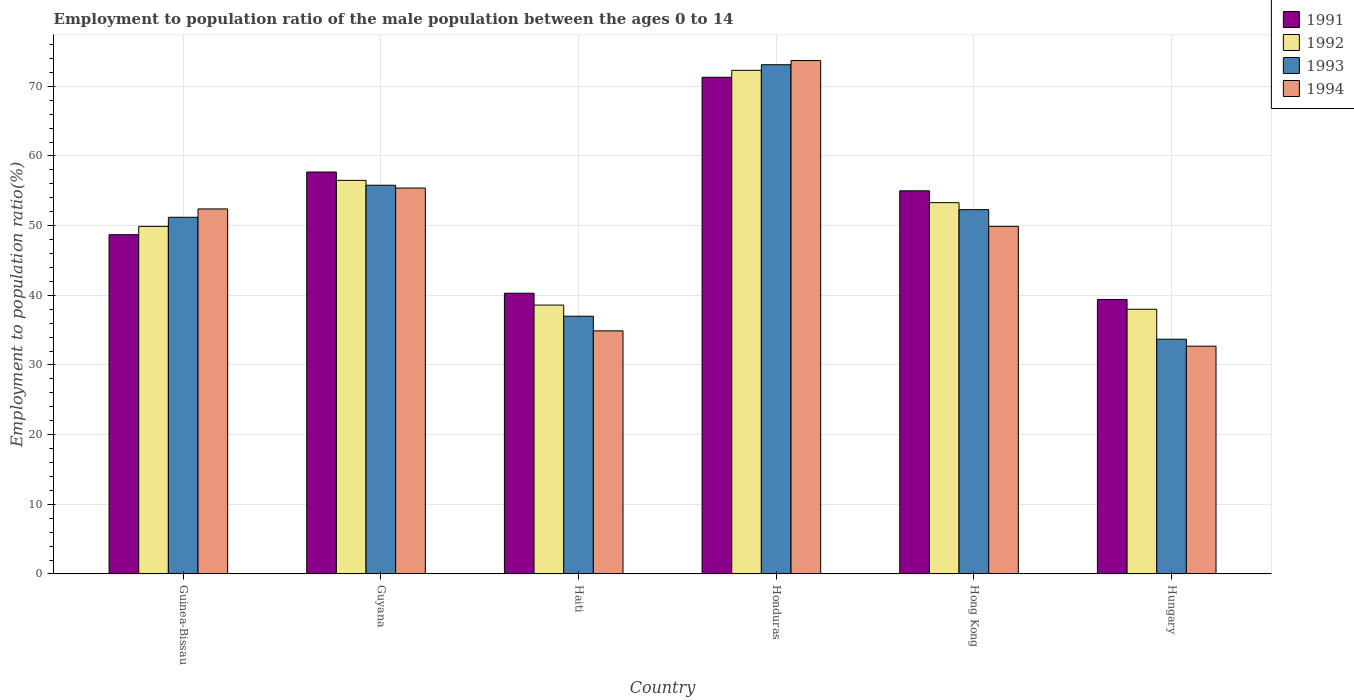How many different coloured bars are there?
Make the answer very short. 4. Are the number of bars per tick equal to the number of legend labels?
Keep it short and to the point. Yes. How many bars are there on the 6th tick from the left?
Provide a short and direct response. 4. How many bars are there on the 6th tick from the right?
Make the answer very short. 4. What is the label of the 5th group of bars from the left?
Make the answer very short. Hong Kong. In how many cases, is the number of bars for a given country not equal to the number of legend labels?
Your answer should be very brief. 0. What is the employment to population ratio in 1994 in Honduras?
Offer a very short reply. 73.7. Across all countries, what is the maximum employment to population ratio in 1992?
Your answer should be compact. 72.3. In which country was the employment to population ratio in 1992 maximum?
Your response must be concise. Honduras. In which country was the employment to population ratio in 1993 minimum?
Give a very brief answer. Hungary. What is the total employment to population ratio in 1991 in the graph?
Your answer should be very brief. 312.4. What is the difference between the employment to population ratio in 1993 in Guinea-Bissau and that in Hong Kong?
Provide a succinct answer. -1.1. What is the difference between the employment to population ratio in 1994 in Guyana and the employment to population ratio in 1993 in Hong Kong?
Your answer should be compact. 3.1. What is the average employment to population ratio in 1991 per country?
Keep it short and to the point. 52.07. In how many countries, is the employment to population ratio in 1994 greater than 52 %?
Offer a terse response. 3. What is the ratio of the employment to population ratio in 1991 in Guinea-Bissau to that in Haiti?
Keep it short and to the point. 1.21. Is the employment to population ratio in 1993 in Guinea-Bissau less than that in Hungary?
Your response must be concise. No. What is the difference between the highest and the second highest employment to population ratio in 1993?
Offer a very short reply. 20.8. What is the difference between the highest and the lowest employment to population ratio in 1994?
Provide a succinct answer. 41. In how many countries, is the employment to population ratio in 1991 greater than the average employment to population ratio in 1991 taken over all countries?
Keep it short and to the point. 3. Is the sum of the employment to population ratio in 1992 in Guinea-Bissau and Guyana greater than the maximum employment to population ratio in 1993 across all countries?
Make the answer very short. Yes. What does the 2nd bar from the left in Haiti represents?
Give a very brief answer. 1992. Is it the case that in every country, the sum of the employment to population ratio in 1993 and employment to population ratio in 1991 is greater than the employment to population ratio in 1994?
Offer a terse response. Yes. Are all the bars in the graph horizontal?
Ensure brevity in your answer.  No. Are the values on the major ticks of Y-axis written in scientific E-notation?
Your answer should be very brief. No. Where does the legend appear in the graph?
Your answer should be compact. Top right. What is the title of the graph?
Offer a very short reply. Employment to population ratio of the male population between the ages 0 to 14. What is the label or title of the X-axis?
Provide a succinct answer. Country. What is the Employment to population ratio(%) in 1991 in Guinea-Bissau?
Ensure brevity in your answer.  48.7. What is the Employment to population ratio(%) of 1992 in Guinea-Bissau?
Your response must be concise. 49.9. What is the Employment to population ratio(%) in 1993 in Guinea-Bissau?
Offer a terse response. 51.2. What is the Employment to population ratio(%) of 1994 in Guinea-Bissau?
Ensure brevity in your answer.  52.4. What is the Employment to population ratio(%) in 1991 in Guyana?
Your response must be concise. 57.7. What is the Employment to population ratio(%) of 1992 in Guyana?
Make the answer very short. 56.5. What is the Employment to population ratio(%) in 1993 in Guyana?
Provide a short and direct response. 55.8. What is the Employment to population ratio(%) in 1994 in Guyana?
Offer a terse response. 55.4. What is the Employment to population ratio(%) of 1991 in Haiti?
Offer a very short reply. 40.3. What is the Employment to population ratio(%) of 1992 in Haiti?
Provide a succinct answer. 38.6. What is the Employment to population ratio(%) in 1994 in Haiti?
Ensure brevity in your answer.  34.9. What is the Employment to population ratio(%) of 1991 in Honduras?
Your answer should be compact. 71.3. What is the Employment to population ratio(%) in 1992 in Honduras?
Provide a succinct answer. 72.3. What is the Employment to population ratio(%) in 1993 in Honduras?
Offer a very short reply. 73.1. What is the Employment to population ratio(%) in 1994 in Honduras?
Offer a terse response. 73.7. What is the Employment to population ratio(%) in 1992 in Hong Kong?
Your response must be concise. 53.3. What is the Employment to population ratio(%) in 1993 in Hong Kong?
Provide a succinct answer. 52.3. What is the Employment to population ratio(%) of 1994 in Hong Kong?
Provide a short and direct response. 49.9. What is the Employment to population ratio(%) of 1991 in Hungary?
Offer a terse response. 39.4. What is the Employment to population ratio(%) in 1992 in Hungary?
Offer a very short reply. 38. What is the Employment to population ratio(%) in 1993 in Hungary?
Your answer should be compact. 33.7. What is the Employment to population ratio(%) of 1994 in Hungary?
Your response must be concise. 32.7. Across all countries, what is the maximum Employment to population ratio(%) of 1991?
Give a very brief answer. 71.3. Across all countries, what is the maximum Employment to population ratio(%) in 1992?
Make the answer very short. 72.3. Across all countries, what is the maximum Employment to population ratio(%) in 1993?
Ensure brevity in your answer.  73.1. Across all countries, what is the maximum Employment to population ratio(%) of 1994?
Provide a succinct answer. 73.7. Across all countries, what is the minimum Employment to population ratio(%) in 1991?
Offer a terse response. 39.4. Across all countries, what is the minimum Employment to population ratio(%) of 1992?
Make the answer very short. 38. Across all countries, what is the minimum Employment to population ratio(%) in 1993?
Keep it short and to the point. 33.7. Across all countries, what is the minimum Employment to population ratio(%) of 1994?
Offer a very short reply. 32.7. What is the total Employment to population ratio(%) of 1991 in the graph?
Keep it short and to the point. 312.4. What is the total Employment to population ratio(%) of 1992 in the graph?
Your answer should be very brief. 308.6. What is the total Employment to population ratio(%) of 1993 in the graph?
Your answer should be compact. 303.1. What is the total Employment to population ratio(%) of 1994 in the graph?
Provide a succinct answer. 299. What is the difference between the Employment to population ratio(%) in 1991 in Guinea-Bissau and that in Guyana?
Your response must be concise. -9. What is the difference between the Employment to population ratio(%) of 1992 in Guinea-Bissau and that in Guyana?
Ensure brevity in your answer.  -6.6. What is the difference between the Employment to population ratio(%) in 1993 in Guinea-Bissau and that in Guyana?
Keep it short and to the point. -4.6. What is the difference between the Employment to population ratio(%) in 1991 in Guinea-Bissau and that in Haiti?
Your answer should be very brief. 8.4. What is the difference between the Employment to population ratio(%) in 1992 in Guinea-Bissau and that in Haiti?
Make the answer very short. 11.3. What is the difference between the Employment to population ratio(%) of 1993 in Guinea-Bissau and that in Haiti?
Your response must be concise. 14.2. What is the difference between the Employment to population ratio(%) of 1991 in Guinea-Bissau and that in Honduras?
Keep it short and to the point. -22.6. What is the difference between the Employment to population ratio(%) in 1992 in Guinea-Bissau and that in Honduras?
Provide a succinct answer. -22.4. What is the difference between the Employment to population ratio(%) of 1993 in Guinea-Bissau and that in Honduras?
Your answer should be compact. -21.9. What is the difference between the Employment to population ratio(%) in 1994 in Guinea-Bissau and that in Honduras?
Your response must be concise. -21.3. What is the difference between the Employment to population ratio(%) of 1991 in Guinea-Bissau and that in Hong Kong?
Provide a succinct answer. -6.3. What is the difference between the Employment to population ratio(%) in 1992 in Guinea-Bissau and that in Hong Kong?
Provide a succinct answer. -3.4. What is the difference between the Employment to population ratio(%) of 1993 in Guinea-Bissau and that in Hong Kong?
Keep it short and to the point. -1.1. What is the difference between the Employment to population ratio(%) of 1994 in Guinea-Bissau and that in Hong Kong?
Give a very brief answer. 2.5. What is the difference between the Employment to population ratio(%) of 1992 in Guyana and that in Haiti?
Give a very brief answer. 17.9. What is the difference between the Employment to population ratio(%) of 1993 in Guyana and that in Haiti?
Provide a short and direct response. 18.8. What is the difference between the Employment to population ratio(%) of 1991 in Guyana and that in Honduras?
Provide a short and direct response. -13.6. What is the difference between the Employment to population ratio(%) of 1992 in Guyana and that in Honduras?
Provide a short and direct response. -15.8. What is the difference between the Employment to population ratio(%) of 1993 in Guyana and that in Honduras?
Make the answer very short. -17.3. What is the difference between the Employment to population ratio(%) of 1994 in Guyana and that in Honduras?
Give a very brief answer. -18.3. What is the difference between the Employment to population ratio(%) of 1991 in Guyana and that in Hong Kong?
Provide a short and direct response. 2.7. What is the difference between the Employment to population ratio(%) of 1991 in Guyana and that in Hungary?
Give a very brief answer. 18.3. What is the difference between the Employment to population ratio(%) of 1993 in Guyana and that in Hungary?
Your response must be concise. 22.1. What is the difference between the Employment to population ratio(%) of 1994 in Guyana and that in Hungary?
Your answer should be compact. 22.7. What is the difference between the Employment to population ratio(%) of 1991 in Haiti and that in Honduras?
Your answer should be very brief. -31. What is the difference between the Employment to population ratio(%) of 1992 in Haiti and that in Honduras?
Your response must be concise. -33.7. What is the difference between the Employment to population ratio(%) in 1993 in Haiti and that in Honduras?
Offer a very short reply. -36.1. What is the difference between the Employment to population ratio(%) of 1994 in Haiti and that in Honduras?
Make the answer very short. -38.8. What is the difference between the Employment to population ratio(%) of 1991 in Haiti and that in Hong Kong?
Keep it short and to the point. -14.7. What is the difference between the Employment to population ratio(%) in 1992 in Haiti and that in Hong Kong?
Give a very brief answer. -14.7. What is the difference between the Employment to population ratio(%) of 1993 in Haiti and that in Hong Kong?
Your answer should be very brief. -15.3. What is the difference between the Employment to population ratio(%) of 1994 in Haiti and that in Hungary?
Offer a very short reply. 2.2. What is the difference between the Employment to population ratio(%) of 1991 in Honduras and that in Hong Kong?
Make the answer very short. 16.3. What is the difference between the Employment to population ratio(%) in 1992 in Honduras and that in Hong Kong?
Your answer should be compact. 19. What is the difference between the Employment to population ratio(%) of 1993 in Honduras and that in Hong Kong?
Offer a very short reply. 20.8. What is the difference between the Employment to population ratio(%) in 1994 in Honduras and that in Hong Kong?
Your response must be concise. 23.8. What is the difference between the Employment to population ratio(%) in 1991 in Honduras and that in Hungary?
Provide a succinct answer. 31.9. What is the difference between the Employment to population ratio(%) of 1992 in Honduras and that in Hungary?
Provide a short and direct response. 34.3. What is the difference between the Employment to population ratio(%) in 1993 in Honduras and that in Hungary?
Make the answer very short. 39.4. What is the difference between the Employment to population ratio(%) in 1993 in Hong Kong and that in Hungary?
Provide a succinct answer. 18.6. What is the difference between the Employment to population ratio(%) in 1994 in Hong Kong and that in Hungary?
Offer a very short reply. 17.2. What is the difference between the Employment to population ratio(%) in 1991 in Guinea-Bissau and the Employment to population ratio(%) in 1992 in Guyana?
Provide a short and direct response. -7.8. What is the difference between the Employment to population ratio(%) in 1991 in Guinea-Bissau and the Employment to population ratio(%) in 1993 in Guyana?
Your answer should be compact. -7.1. What is the difference between the Employment to population ratio(%) in 1993 in Guinea-Bissau and the Employment to population ratio(%) in 1994 in Guyana?
Make the answer very short. -4.2. What is the difference between the Employment to population ratio(%) of 1991 in Guinea-Bissau and the Employment to population ratio(%) of 1993 in Haiti?
Your answer should be very brief. 11.7. What is the difference between the Employment to population ratio(%) of 1991 in Guinea-Bissau and the Employment to population ratio(%) of 1994 in Haiti?
Ensure brevity in your answer.  13.8. What is the difference between the Employment to population ratio(%) in 1992 in Guinea-Bissau and the Employment to population ratio(%) in 1993 in Haiti?
Make the answer very short. 12.9. What is the difference between the Employment to population ratio(%) in 1992 in Guinea-Bissau and the Employment to population ratio(%) in 1994 in Haiti?
Offer a terse response. 15. What is the difference between the Employment to population ratio(%) of 1991 in Guinea-Bissau and the Employment to population ratio(%) of 1992 in Honduras?
Make the answer very short. -23.6. What is the difference between the Employment to population ratio(%) of 1991 in Guinea-Bissau and the Employment to population ratio(%) of 1993 in Honduras?
Offer a very short reply. -24.4. What is the difference between the Employment to population ratio(%) of 1991 in Guinea-Bissau and the Employment to population ratio(%) of 1994 in Honduras?
Provide a succinct answer. -25. What is the difference between the Employment to population ratio(%) in 1992 in Guinea-Bissau and the Employment to population ratio(%) in 1993 in Honduras?
Keep it short and to the point. -23.2. What is the difference between the Employment to population ratio(%) in 1992 in Guinea-Bissau and the Employment to population ratio(%) in 1994 in Honduras?
Provide a short and direct response. -23.8. What is the difference between the Employment to population ratio(%) of 1993 in Guinea-Bissau and the Employment to population ratio(%) of 1994 in Honduras?
Your answer should be compact. -22.5. What is the difference between the Employment to population ratio(%) of 1991 in Guinea-Bissau and the Employment to population ratio(%) of 1993 in Hong Kong?
Offer a very short reply. -3.6. What is the difference between the Employment to population ratio(%) of 1991 in Guinea-Bissau and the Employment to population ratio(%) of 1994 in Hong Kong?
Provide a succinct answer. -1.2. What is the difference between the Employment to population ratio(%) in 1992 in Guinea-Bissau and the Employment to population ratio(%) in 1994 in Hong Kong?
Make the answer very short. 0. What is the difference between the Employment to population ratio(%) of 1991 in Guinea-Bissau and the Employment to population ratio(%) of 1992 in Hungary?
Provide a short and direct response. 10.7. What is the difference between the Employment to population ratio(%) in 1991 in Guinea-Bissau and the Employment to population ratio(%) in 1993 in Hungary?
Make the answer very short. 15. What is the difference between the Employment to population ratio(%) in 1992 in Guinea-Bissau and the Employment to population ratio(%) in 1993 in Hungary?
Your response must be concise. 16.2. What is the difference between the Employment to population ratio(%) in 1991 in Guyana and the Employment to population ratio(%) in 1993 in Haiti?
Your response must be concise. 20.7. What is the difference between the Employment to population ratio(%) in 1991 in Guyana and the Employment to population ratio(%) in 1994 in Haiti?
Keep it short and to the point. 22.8. What is the difference between the Employment to population ratio(%) in 1992 in Guyana and the Employment to population ratio(%) in 1994 in Haiti?
Keep it short and to the point. 21.6. What is the difference between the Employment to population ratio(%) in 1993 in Guyana and the Employment to population ratio(%) in 1994 in Haiti?
Offer a very short reply. 20.9. What is the difference between the Employment to population ratio(%) in 1991 in Guyana and the Employment to population ratio(%) in 1992 in Honduras?
Provide a succinct answer. -14.6. What is the difference between the Employment to population ratio(%) in 1991 in Guyana and the Employment to population ratio(%) in 1993 in Honduras?
Provide a succinct answer. -15.4. What is the difference between the Employment to population ratio(%) of 1991 in Guyana and the Employment to population ratio(%) of 1994 in Honduras?
Offer a terse response. -16. What is the difference between the Employment to population ratio(%) in 1992 in Guyana and the Employment to population ratio(%) in 1993 in Honduras?
Ensure brevity in your answer.  -16.6. What is the difference between the Employment to population ratio(%) of 1992 in Guyana and the Employment to population ratio(%) of 1994 in Honduras?
Make the answer very short. -17.2. What is the difference between the Employment to population ratio(%) of 1993 in Guyana and the Employment to population ratio(%) of 1994 in Honduras?
Offer a very short reply. -17.9. What is the difference between the Employment to population ratio(%) in 1991 in Guyana and the Employment to population ratio(%) in 1993 in Hong Kong?
Give a very brief answer. 5.4. What is the difference between the Employment to population ratio(%) of 1991 in Guyana and the Employment to population ratio(%) of 1994 in Hong Kong?
Give a very brief answer. 7.8. What is the difference between the Employment to population ratio(%) in 1992 in Guyana and the Employment to population ratio(%) in 1994 in Hong Kong?
Give a very brief answer. 6.6. What is the difference between the Employment to population ratio(%) in 1993 in Guyana and the Employment to population ratio(%) in 1994 in Hong Kong?
Make the answer very short. 5.9. What is the difference between the Employment to population ratio(%) in 1991 in Guyana and the Employment to population ratio(%) in 1993 in Hungary?
Keep it short and to the point. 24. What is the difference between the Employment to population ratio(%) of 1991 in Guyana and the Employment to population ratio(%) of 1994 in Hungary?
Your answer should be very brief. 25. What is the difference between the Employment to population ratio(%) of 1992 in Guyana and the Employment to population ratio(%) of 1993 in Hungary?
Give a very brief answer. 22.8. What is the difference between the Employment to population ratio(%) of 1992 in Guyana and the Employment to population ratio(%) of 1994 in Hungary?
Provide a short and direct response. 23.8. What is the difference between the Employment to population ratio(%) of 1993 in Guyana and the Employment to population ratio(%) of 1994 in Hungary?
Make the answer very short. 23.1. What is the difference between the Employment to population ratio(%) of 1991 in Haiti and the Employment to population ratio(%) of 1992 in Honduras?
Provide a succinct answer. -32. What is the difference between the Employment to population ratio(%) in 1991 in Haiti and the Employment to population ratio(%) in 1993 in Honduras?
Ensure brevity in your answer.  -32.8. What is the difference between the Employment to population ratio(%) of 1991 in Haiti and the Employment to population ratio(%) of 1994 in Honduras?
Provide a succinct answer. -33.4. What is the difference between the Employment to population ratio(%) of 1992 in Haiti and the Employment to population ratio(%) of 1993 in Honduras?
Ensure brevity in your answer.  -34.5. What is the difference between the Employment to population ratio(%) in 1992 in Haiti and the Employment to population ratio(%) in 1994 in Honduras?
Make the answer very short. -35.1. What is the difference between the Employment to population ratio(%) in 1993 in Haiti and the Employment to population ratio(%) in 1994 in Honduras?
Keep it short and to the point. -36.7. What is the difference between the Employment to population ratio(%) in 1991 in Haiti and the Employment to population ratio(%) in 1992 in Hong Kong?
Ensure brevity in your answer.  -13. What is the difference between the Employment to population ratio(%) of 1992 in Haiti and the Employment to population ratio(%) of 1993 in Hong Kong?
Your answer should be compact. -13.7. What is the difference between the Employment to population ratio(%) of 1992 in Haiti and the Employment to population ratio(%) of 1994 in Hong Kong?
Keep it short and to the point. -11.3. What is the difference between the Employment to population ratio(%) in 1993 in Haiti and the Employment to population ratio(%) in 1994 in Hong Kong?
Your answer should be very brief. -12.9. What is the difference between the Employment to population ratio(%) in 1991 in Haiti and the Employment to population ratio(%) in 1992 in Hungary?
Ensure brevity in your answer.  2.3. What is the difference between the Employment to population ratio(%) in 1991 in Haiti and the Employment to population ratio(%) in 1994 in Hungary?
Make the answer very short. 7.6. What is the difference between the Employment to population ratio(%) in 1992 in Haiti and the Employment to population ratio(%) in 1994 in Hungary?
Ensure brevity in your answer.  5.9. What is the difference between the Employment to population ratio(%) in 1991 in Honduras and the Employment to population ratio(%) in 1994 in Hong Kong?
Your answer should be very brief. 21.4. What is the difference between the Employment to population ratio(%) in 1992 in Honduras and the Employment to population ratio(%) in 1994 in Hong Kong?
Give a very brief answer. 22.4. What is the difference between the Employment to population ratio(%) of 1993 in Honduras and the Employment to population ratio(%) of 1994 in Hong Kong?
Ensure brevity in your answer.  23.2. What is the difference between the Employment to population ratio(%) of 1991 in Honduras and the Employment to population ratio(%) of 1992 in Hungary?
Give a very brief answer. 33.3. What is the difference between the Employment to population ratio(%) in 1991 in Honduras and the Employment to population ratio(%) in 1993 in Hungary?
Your answer should be very brief. 37.6. What is the difference between the Employment to population ratio(%) in 1991 in Honduras and the Employment to population ratio(%) in 1994 in Hungary?
Your answer should be compact. 38.6. What is the difference between the Employment to population ratio(%) in 1992 in Honduras and the Employment to population ratio(%) in 1993 in Hungary?
Your response must be concise. 38.6. What is the difference between the Employment to population ratio(%) of 1992 in Honduras and the Employment to population ratio(%) of 1994 in Hungary?
Your answer should be compact. 39.6. What is the difference between the Employment to population ratio(%) of 1993 in Honduras and the Employment to population ratio(%) of 1994 in Hungary?
Offer a terse response. 40.4. What is the difference between the Employment to population ratio(%) in 1991 in Hong Kong and the Employment to population ratio(%) in 1992 in Hungary?
Your response must be concise. 17. What is the difference between the Employment to population ratio(%) of 1991 in Hong Kong and the Employment to population ratio(%) of 1993 in Hungary?
Your response must be concise. 21.3. What is the difference between the Employment to population ratio(%) of 1991 in Hong Kong and the Employment to population ratio(%) of 1994 in Hungary?
Provide a succinct answer. 22.3. What is the difference between the Employment to population ratio(%) of 1992 in Hong Kong and the Employment to population ratio(%) of 1993 in Hungary?
Make the answer very short. 19.6. What is the difference between the Employment to population ratio(%) of 1992 in Hong Kong and the Employment to population ratio(%) of 1994 in Hungary?
Provide a succinct answer. 20.6. What is the difference between the Employment to population ratio(%) in 1993 in Hong Kong and the Employment to population ratio(%) in 1994 in Hungary?
Offer a very short reply. 19.6. What is the average Employment to population ratio(%) in 1991 per country?
Your answer should be compact. 52.07. What is the average Employment to population ratio(%) of 1992 per country?
Provide a succinct answer. 51.43. What is the average Employment to population ratio(%) of 1993 per country?
Provide a short and direct response. 50.52. What is the average Employment to population ratio(%) of 1994 per country?
Offer a terse response. 49.83. What is the difference between the Employment to population ratio(%) in 1991 and Employment to population ratio(%) in 1994 in Guinea-Bissau?
Ensure brevity in your answer.  -3.7. What is the difference between the Employment to population ratio(%) in 1993 and Employment to population ratio(%) in 1994 in Guinea-Bissau?
Your response must be concise. -1.2. What is the difference between the Employment to population ratio(%) of 1991 and Employment to population ratio(%) of 1992 in Guyana?
Your answer should be compact. 1.2. What is the difference between the Employment to population ratio(%) of 1993 and Employment to population ratio(%) of 1994 in Guyana?
Your answer should be very brief. 0.4. What is the difference between the Employment to population ratio(%) of 1992 and Employment to population ratio(%) of 1993 in Honduras?
Provide a short and direct response. -0.8. What is the difference between the Employment to population ratio(%) of 1992 and Employment to population ratio(%) of 1994 in Honduras?
Keep it short and to the point. -1.4. What is the difference between the Employment to population ratio(%) of 1991 and Employment to population ratio(%) of 1993 in Hong Kong?
Offer a terse response. 2.7. What is the difference between the Employment to population ratio(%) in 1991 and Employment to population ratio(%) in 1994 in Hong Kong?
Your response must be concise. 5.1. What is the difference between the Employment to population ratio(%) of 1991 and Employment to population ratio(%) of 1992 in Hungary?
Your answer should be very brief. 1.4. What is the difference between the Employment to population ratio(%) of 1993 and Employment to population ratio(%) of 1994 in Hungary?
Ensure brevity in your answer.  1. What is the ratio of the Employment to population ratio(%) in 1991 in Guinea-Bissau to that in Guyana?
Your answer should be compact. 0.84. What is the ratio of the Employment to population ratio(%) in 1992 in Guinea-Bissau to that in Guyana?
Keep it short and to the point. 0.88. What is the ratio of the Employment to population ratio(%) of 1993 in Guinea-Bissau to that in Guyana?
Offer a terse response. 0.92. What is the ratio of the Employment to population ratio(%) of 1994 in Guinea-Bissau to that in Guyana?
Make the answer very short. 0.95. What is the ratio of the Employment to population ratio(%) in 1991 in Guinea-Bissau to that in Haiti?
Provide a short and direct response. 1.21. What is the ratio of the Employment to population ratio(%) in 1992 in Guinea-Bissau to that in Haiti?
Make the answer very short. 1.29. What is the ratio of the Employment to population ratio(%) of 1993 in Guinea-Bissau to that in Haiti?
Ensure brevity in your answer.  1.38. What is the ratio of the Employment to population ratio(%) in 1994 in Guinea-Bissau to that in Haiti?
Offer a terse response. 1.5. What is the ratio of the Employment to population ratio(%) in 1991 in Guinea-Bissau to that in Honduras?
Your response must be concise. 0.68. What is the ratio of the Employment to population ratio(%) of 1992 in Guinea-Bissau to that in Honduras?
Your answer should be very brief. 0.69. What is the ratio of the Employment to population ratio(%) in 1993 in Guinea-Bissau to that in Honduras?
Ensure brevity in your answer.  0.7. What is the ratio of the Employment to population ratio(%) in 1994 in Guinea-Bissau to that in Honduras?
Ensure brevity in your answer.  0.71. What is the ratio of the Employment to population ratio(%) of 1991 in Guinea-Bissau to that in Hong Kong?
Offer a very short reply. 0.89. What is the ratio of the Employment to population ratio(%) in 1992 in Guinea-Bissau to that in Hong Kong?
Your answer should be very brief. 0.94. What is the ratio of the Employment to population ratio(%) of 1993 in Guinea-Bissau to that in Hong Kong?
Provide a succinct answer. 0.98. What is the ratio of the Employment to population ratio(%) in 1994 in Guinea-Bissau to that in Hong Kong?
Offer a very short reply. 1.05. What is the ratio of the Employment to population ratio(%) in 1991 in Guinea-Bissau to that in Hungary?
Your answer should be very brief. 1.24. What is the ratio of the Employment to population ratio(%) of 1992 in Guinea-Bissau to that in Hungary?
Ensure brevity in your answer.  1.31. What is the ratio of the Employment to population ratio(%) in 1993 in Guinea-Bissau to that in Hungary?
Give a very brief answer. 1.52. What is the ratio of the Employment to population ratio(%) of 1994 in Guinea-Bissau to that in Hungary?
Offer a terse response. 1.6. What is the ratio of the Employment to population ratio(%) of 1991 in Guyana to that in Haiti?
Your answer should be compact. 1.43. What is the ratio of the Employment to population ratio(%) in 1992 in Guyana to that in Haiti?
Provide a short and direct response. 1.46. What is the ratio of the Employment to population ratio(%) in 1993 in Guyana to that in Haiti?
Keep it short and to the point. 1.51. What is the ratio of the Employment to population ratio(%) in 1994 in Guyana to that in Haiti?
Offer a very short reply. 1.59. What is the ratio of the Employment to population ratio(%) of 1991 in Guyana to that in Honduras?
Provide a short and direct response. 0.81. What is the ratio of the Employment to population ratio(%) in 1992 in Guyana to that in Honduras?
Provide a succinct answer. 0.78. What is the ratio of the Employment to population ratio(%) of 1993 in Guyana to that in Honduras?
Offer a terse response. 0.76. What is the ratio of the Employment to population ratio(%) in 1994 in Guyana to that in Honduras?
Provide a succinct answer. 0.75. What is the ratio of the Employment to population ratio(%) in 1991 in Guyana to that in Hong Kong?
Ensure brevity in your answer.  1.05. What is the ratio of the Employment to population ratio(%) of 1992 in Guyana to that in Hong Kong?
Give a very brief answer. 1.06. What is the ratio of the Employment to population ratio(%) of 1993 in Guyana to that in Hong Kong?
Your response must be concise. 1.07. What is the ratio of the Employment to population ratio(%) in 1994 in Guyana to that in Hong Kong?
Keep it short and to the point. 1.11. What is the ratio of the Employment to population ratio(%) of 1991 in Guyana to that in Hungary?
Make the answer very short. 1.46. What is the ratio of the Employment to population ratio(%) of 1992 in Guyana to that in Hungary?
Your answer should be very brief. 1.49. What is the ratio of the Employment to population ratio(%) in 1993 in Guyana to that in Hungary?
Offer a terse response. 1.66. What is the ratio of the Employment to population ratio(%) of 1994 in Guyana to that in Hungary?
Offer a very short reply. 1.69. What is the ratio of the Employment to population ratio(%) of 1991 in Haiti to that in Honduras?
Ensure brevity in your answer.  0.57. What is the ratio of the Employment to population ratio(%) of 1992 in Haiti to that in Honduras?
Your answer should be very brief. 0.53. What is the ratio of the Employment to population ratio(%) in 1993 in Haiti to that in Honduras?
Ensure brevity in your answer.  0.51. What is the ratio of the Employment to population ratio(%) of 1994 in Haiti to that in Honduras?
Keep it short and to the point. 0.47. What is the ratio of the Employment to population ratio(%) in 1991 in Haiti to that in Hong Kong?
Make the answer very short. 0.73. What is the ratio of the Employment to population ratio(%) in 1992 in Haiti to that in Hong Kong?
Your response must be concise. 0.72. What is the ratio of the Employment to population ratio(%) in 1993 in Haiti to that in Hong Kong?
Offer a terse response. 0.71. What is the ratio of the Employment to population ratio(%) in 1994 in Haiti to that in Hong Kong?
Offer a terse response. 0.7. What is the ratio of the Employment to population ratio(%) of 1991 in Haiti to that in Hungary?
Make the answer very short. 1.02. What is the ratio of the Employment to population ratio(%) of 1992 in Haiti to that in Hungary?
Your answer should be very brief. 1.02. What is the ratio of the Employment to population ratio(%) of 1993 in Haiti to that in Hungary?
Your answer should be very brief. 1.1. What is the ratio of the Employment to population ratio(%) of 1994 in Haiti to that in Hungary?
Make the answer very short. 1.07. What is the ratio of the Employment to population ratio(%) of 1991 in Honduras to that in Hong Kong?
Offer a very short reply. 1.3. What is the ratio of the Employment to population ratio(%) of 1992 in Honduras to that in Hong Kong?
Your response must be concise. 1.36. What is the ratio of the Employment to population ratio(%) in 1993 in Honduras to that in Hong Kong?
Your answer should be very brief. 1.4. What is the ratio of the Employment to population ratio(%) of 1994 in Honduras to that in Hong Kong?
Make the answer very short. 1.48. What is the ratio of the Employment to population ratio(%) of 1991 in Honduras to that in Hungary?
Give a very brief answer. 1.81. What is the ratio of the Employment to population ratio(%) of 1992 in Honduras to that in Hungary?
Ensure brevity in your answer.  1.9. What is the ratio of the Employment to population ratio(%) in 1993 in Honduras to that in Hungary?
Your response must be concise. 2.17. What is the ratio of the Employment to population ratio(%) in 1994 in Honduras to that in Hungary?
Your answer should be compact. 2.25. What is the ratio of the Employment to population ratio(%) of 1991 in Hong Kong to that in Hungary?
Give a very brief answer. 1.4. What is the ratio of the Employment to population ratio(%) in 1992 in Hong Kong to that in Hungary?
Offer a terse response. 1.4. What is the ratio of the Employment to population ratio(%) in 1993 in Hong Kong to that in Hungary?
Make the answer very short. 1.55. What is the ratio of the Employment to population ratio(%) in 1994 in Hong Kong to that in Hungary?
Your answer should be very brief. 1.53. What is the difference between the highest and the second highest Employment to population ratio(%) in 1993?
Keep it short and to the point. 17.3. What is the difference between the highest and the lowest Employment to population ratio(%) in 1991?
Give a very brief answer. 31.9. What is the difference between the highest and the lowest Employment to population ratio(%) in 1992?
Provide a succinct answer. 34.3. What is the difference between the highest and the lowest Employment to population ratio(%) in 1993?
Give a very brief answer. 39.4. 